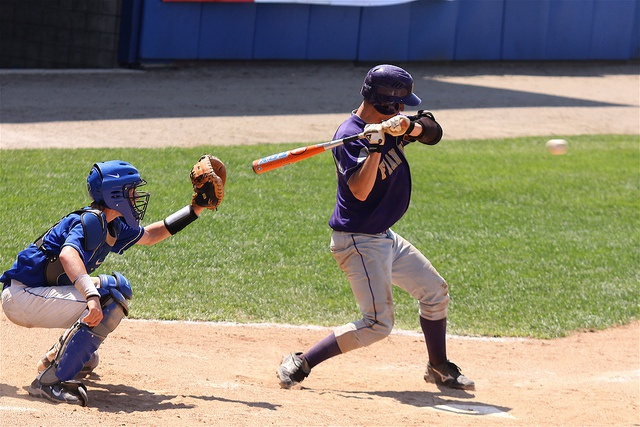Describe the objects in this image and their specific colors. I can see people in black and gray tones, people in black, navy, darkgray, and gray tones, baseball glove in black, maroon, brown, and tan tones, baseball bat in black, red, white, and brown tones, and sports ball in black, tan, and ivory tones in this image. 